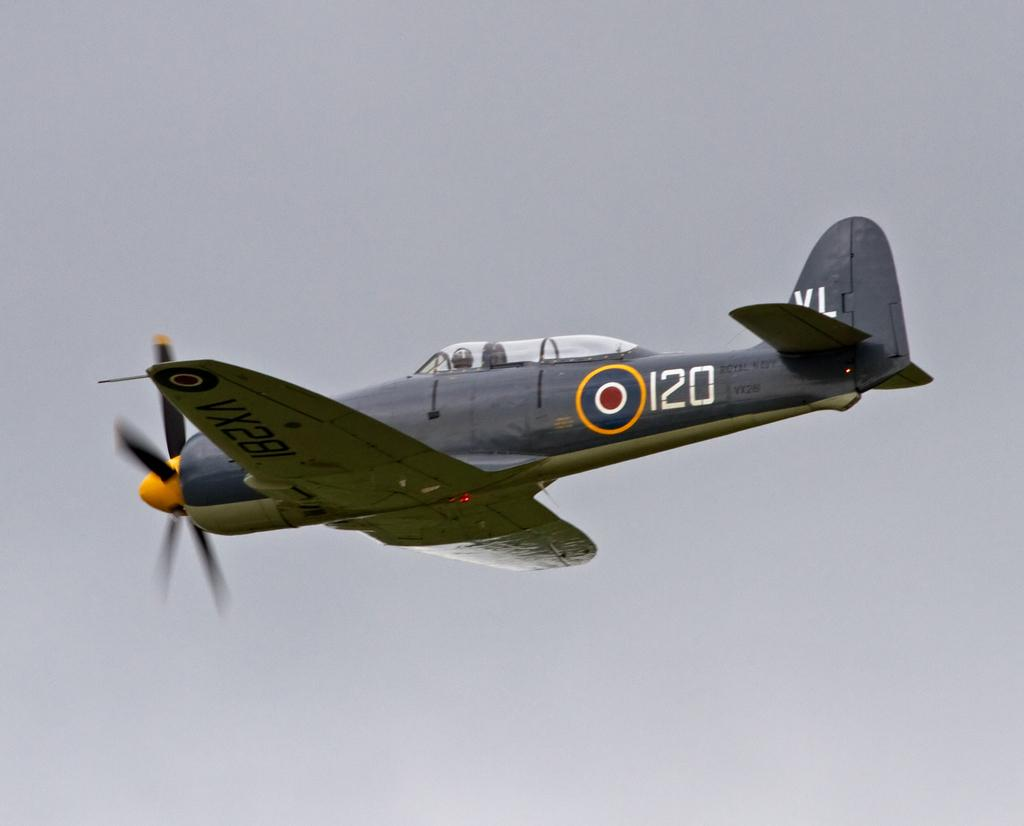<image>
Offer a succinct explanation of the picture presented. An old plane with 120 on the side flies in the sky 